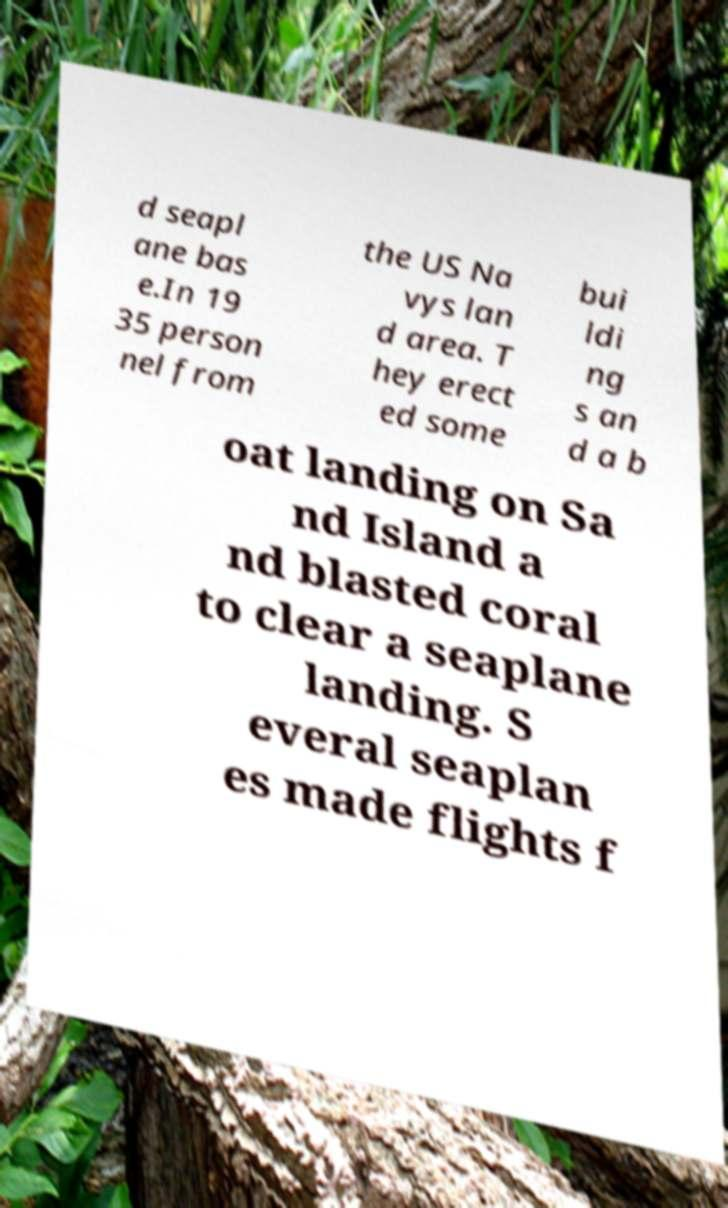There's text embedded in this image that I need extracted. Can you transcribe it verbatim? d seapl ane bas e.In 19 35 person nel from the US Na vys lan d area. T hey erect ed some bui ldi ng s an d a b oat landing on Sa nd Island a nd blasted coral to clear a seaplane landing. S everal seaplan es made flights f 